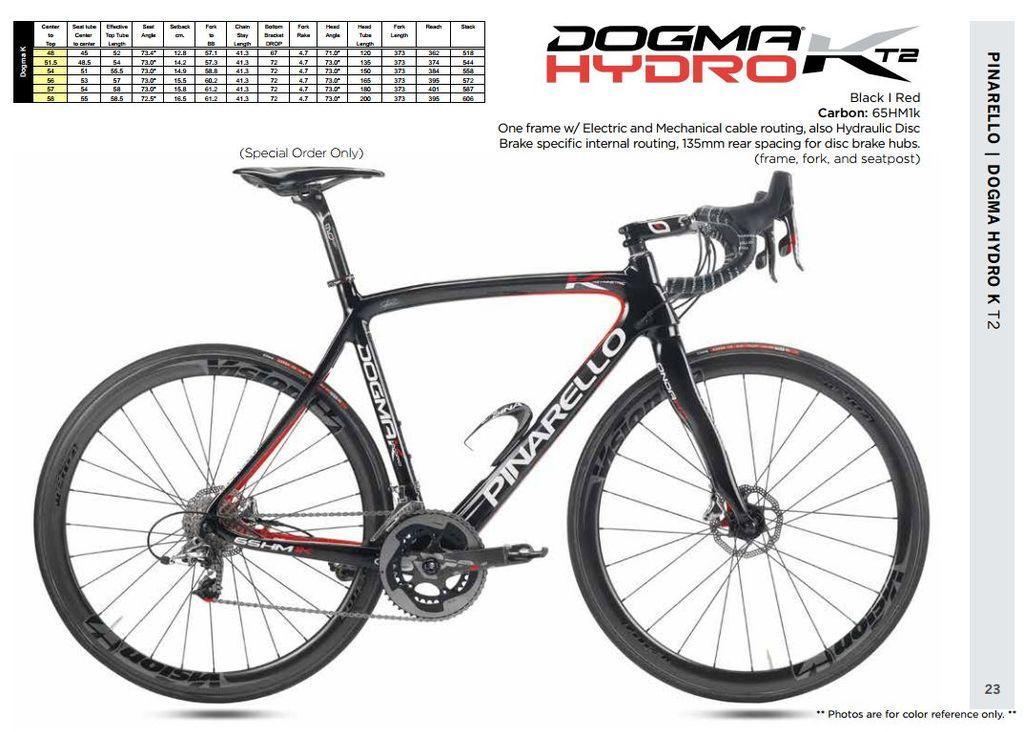What is the color of the bicycle in the image? The bicycle is black in color. How does the feeling of the rat affect the line in the image? There is no rat or line present in the image, and therefore no such interaction can be observed. 